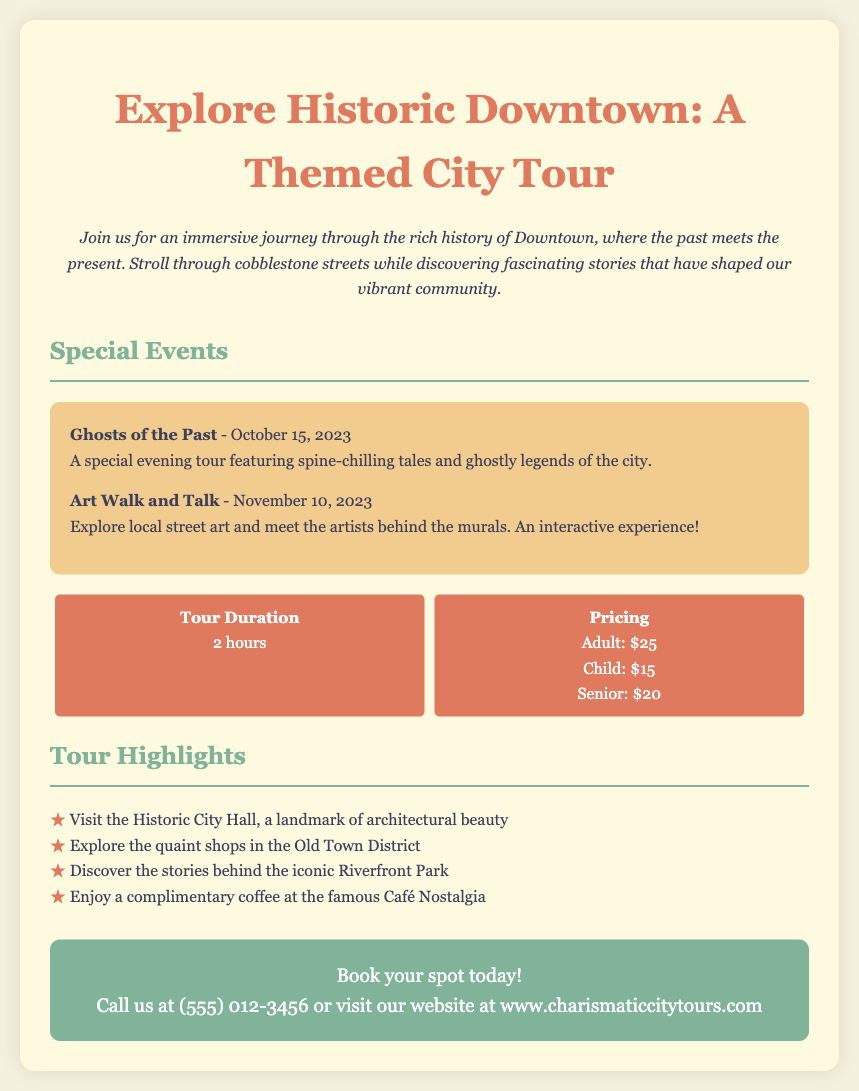what is the title of the tour? The title of the tour is prominently displayed at the top of the document.
Answer: Explore Historic Downtown: A Themed City Tour how long is the tour? The duration of the tour is specified in the tour information section.
Answer: 2 hours what is the pricing for children? The pricing for children is listed under the pricing section of the document.
Answer: $15 when is the "Ghosts of the Past" event taking place? The date of the "Ghosts of the Past" event is mentioned in the special events section.
Answer: October 15, 2023 which landmark is highlighted in the tour? The document lists highlights of the tour, including notable landmarks.
Answer: Historic City Hall what complimentary item is offered during the tour? The tour highlights mention a complimentary item available to participants.
Answer: coffee how many special events are mentioned in the document? The document lists special events, which can be counted for this answer.
Answer: 2 what is the website to book the tour? The website information is provided in the call-to-action section of the document.
Answer: www.charismaticcitytours.com 